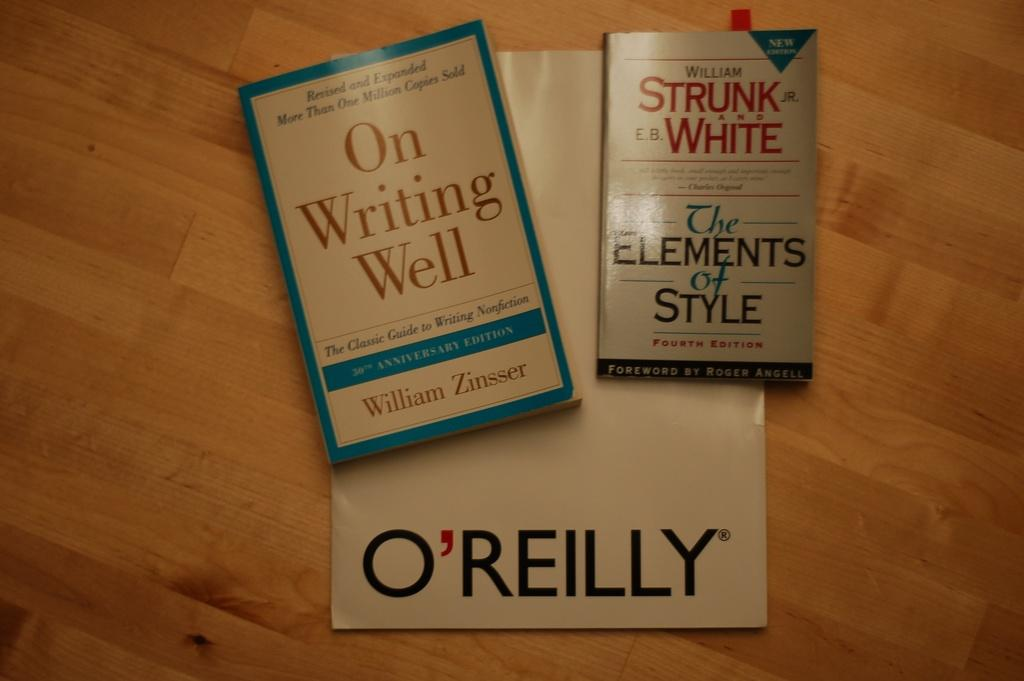<image>
Share a concise interpretation of the image provided. A book titled On Writing Well is on a table next to another book. 